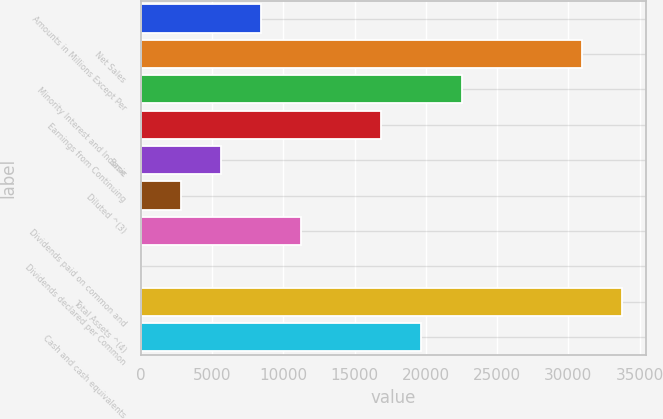Convert chart. <chart><loc_0><loc_0><loc_500><loc_500><bar_chart><fcel>Amounts in Millions Except Per<fcel>Net Sales<fcel>Minority Interest and Income<fcel>Earnings from Continuing<fcel>Basic<fcel>Diluted ^(3)<fcel>Dividends paid on common and<fcel>Dividends declared per Common<fcel>Total Assets ^(4)<fcel>Cash and cash equivalents<nl><fcel>8442.19<fcel>30951.7<fcel>22510.6<fcel>16883.3<fcel>5628.5<fcel>2814.81<fcel>11255.9<fcel>1.12<fcel>33765.4<fcel>19697<nl></chart> 